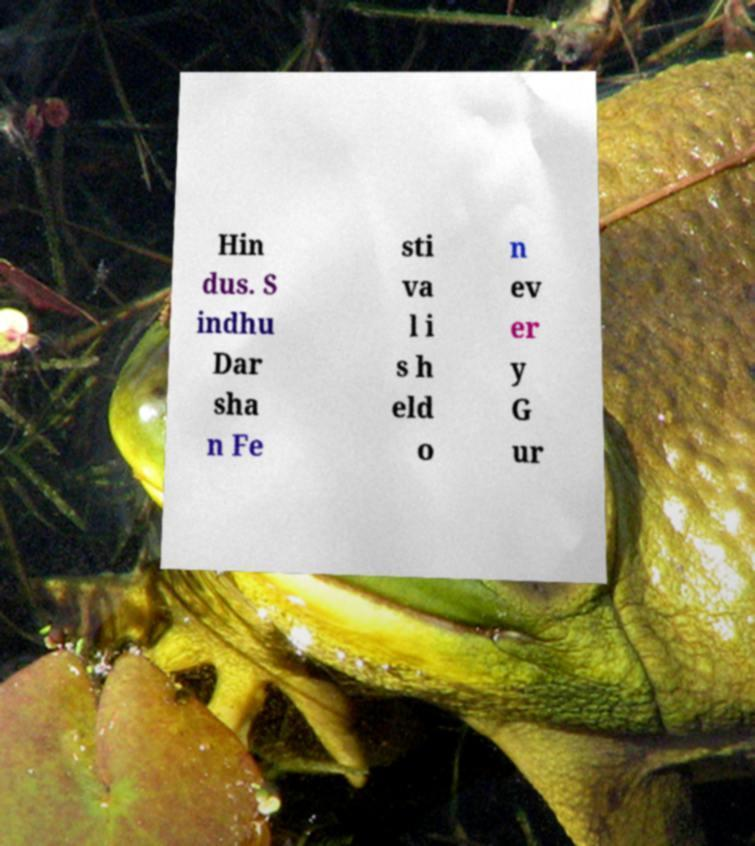Can you accurately transcribe the text from the provided image for me? Hin dus. S indhu Dar sha n Fe sti va l i s h eld o n ev er y G ur 